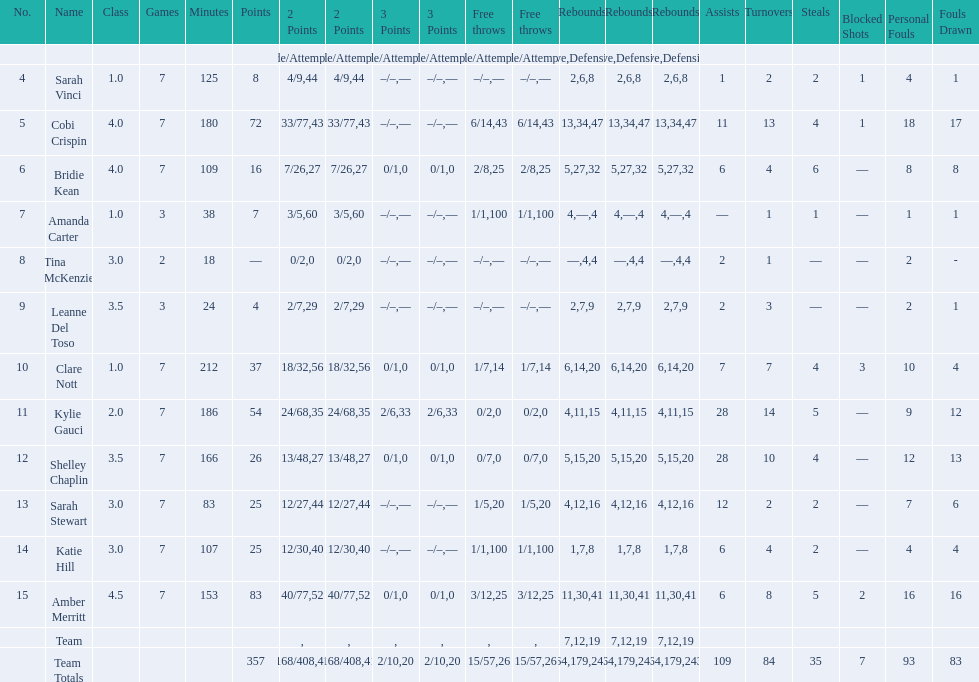After playing seven games, how many players individual points were above 30? 4. 